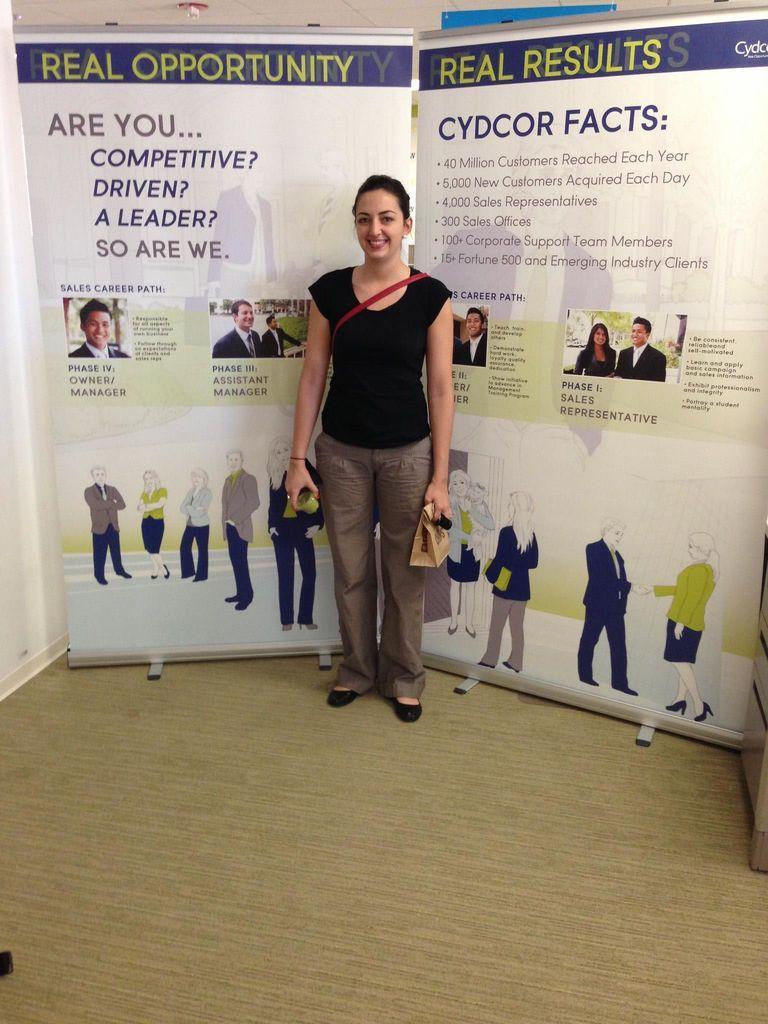Describe this image in one or two sentences. In this image there is a woman standing and smiling, and in the background there are boards. 